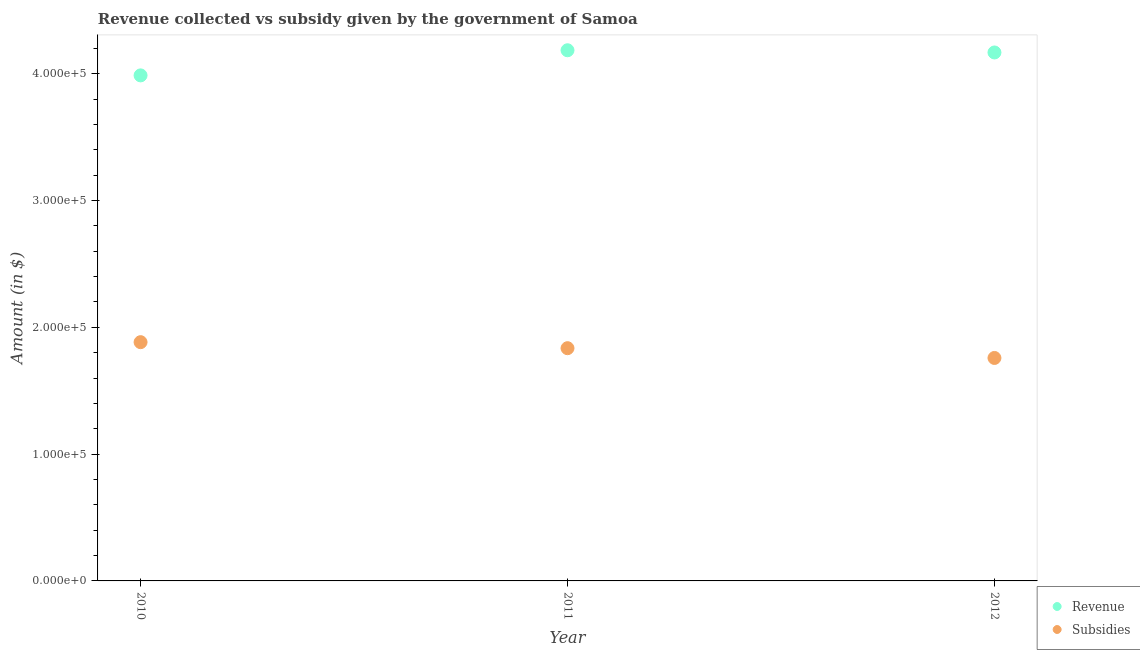What is the amount of subsidies given in 2012?
Your answer should be very brief. 1.76e+05. Across all years, what is the maximum amount of subsidies given?
Your response must be concise. 1.88e+05. Across all years, what is the minimum amount of revenue collected?
Offer a very short reply. 3.99e+05. What is the total amount of subsidies given in the graph?
Offer a very short reply. 5.48e+05. What is the difference between the amount of revenue collected in 2010 and that in 2011?
Your response must be concise. -1.98e+04. What is the difference between the amount of revenue collected in 2010 and the amount of subsidies given in 2012?
Provide a succinct answer. 2.23e+05. What is the average amount of subsidies given per year?
Provide a succinct answer. 1.83e+05. In the year 2011, what is the difference between the amount of revenue collected and amount of subsidies given?
Your answer should be very brief. 2.35e+05. In how many years, is the amount of subsidies given greater than 280000 $?
Give a very brief answer. 0. What is the ratio of the amount of subsidies given in 2010 to that in 2011?
Offer a very short reply. 1.03. Is the amount of subsidies given in 2010 less than that in 2012?
Make the answer very short. No. What is the difference between the highest and the second highest amount of revenue collected?
Provide a short and direct response. 1740.52. What is the difference between the highest and the lowest amount of revenue collected?
Make the answer very short. 1.98e+04. Does the amount of subsidies given monotonically increase over the years?
Ensure brevity in your answer.  No. Is the amount of subsidies given strictly greater than the amount of revenue collected over the years?
Give a very brief answer. No. What is the difference between two consecutive major ticks on the Y-axis?
Provide a succinct answer. 1.00e+05. Does the graph contain any zero values?
Provide a short and direct response. No. Does the graph contain grids?
Ensure brevity in your answer.  No. What is the title of the graph?
Your answer should be very brief. Revenue collected vs subsidy given by the government of Samoa. Does "Male labor force" appear as one of the legend labels in the graph?
Your answer should be very brief. No. What is the label or title of the Y-axis?
Give a very brief answer. Amount (in $). What is the Amount (in $) in Revenue in 2010?
Keep it short and to the point. 3.99e+05. What is the Amount (in $) of Subsidies in 2010?
Provide a short and direct response. 1.88e+05. What is the Amount (in $) in Revenue in 2011?
Make the answer very short. 4.19e+05. What is the Amount (in $) in Subsidies in 2011?
Keep it short and to the point. 1.84e+05. What is the Amount (in $) in Revenue in 2012?
Provide a short and direct response. 4.17e+05. What is the Amount (in $) in Subsidies in 2012?
Give a very brief answer. 1.76e+05. Across all years, what is the maximum Amount (in $) of Revenue?
Your answer should be very brief. 4.19e+05. Across all years, what is the maximum Amount (in $) of Subsidies?
Your answer should be very brief. 1.88e+05. Across all years, what is the minimum Amount (in $) of Revenue?
Keep it short and to the point. 3.99e+05. Across all years, what is the minimum Amount (in $) in Subsidies?
Your answer should be compact. 1.76e+05. What is the total Amount (in $) in Revenue in the graph?
Give a very brief answer. 1.23e+06. What is the total Amount (in $) in Subsidies in the graph?
Make the answer very short. 5.48e+05. What is the difference between the Amount (in $) in Revenue in 2010 and that in 2011?
Offer a very short reply. -1.98e+04. What is the difference between the Amount (in $) of Subsidies in 2010 and that in 2011?
Offer a very short reply. 4748.99. What is the difference between the Amount (in $) in Revenue in 2010 and that in 2012?
Provide a succinct answer. -1.81e+04. What is the difference between the Amount (in $) in Subsidies in 2010 and that in 2012?
Your answer should be very brief. 1.25e+04. What is the difference between the Amount (in $) of Revenue in 2011 and that in 2012?
Offer a terse response. 1740.52. What is the difference between the Amount (in $) of Subsidies in 2011 and that in 2012?
Your answer should be very brief. 7706.28. What is the difference between the Amount (in $) in Revenue in 2010 and the Amount (in $) in Subsidies in 2011?
Make the answer very short. 2.15e+05. What is the difference between the Amount (in $) of Revenue in 2010 and the Amount (in $) of Subsidies in 2012?
Ensure brevity in your answer.  2.23e+05. What is the difference between the Amount (in $) of Revenue in 2011 and the Amount (in $) of Subsidies in 2012?
Offer a terse response. 2.43e+05. What is the average Amount (in $) in Revenue per year?
Your response must be concise. 4.11e+05. What is the average Amount (in $) of Subsidies per year?
Your response must be concise. 1.83e+05. In the year 2010, what is the difference between the Amount (in $) in Revenue and Amount (in $) in Subsidies?
Give a very brief answer. 2.10e+05. In the year 2011, what is the difference between the Amount (in $) in Revenue and Amount (in $) in Subsidies?
Give a very brief answer. 2.35e+05. In the year 2012, what is the difference between the Amount (in $) of Revenue and Amount (in $) of Subsidies?
Provide a short and direct response. 2.41e+05. What is the ratio of the Amount (in $) in Revenue in 2010 to that in 2011?
Provide a short and direct response. 0.95. What is the ratio of the Amount (in $) in Subsidies in 2010 to that in 2011?
Your answer should be very brief. 1.03. What is the ratio of the Amount (in $) of Revenue in 2010 to that in 2012?
Your answer should be compact. 0.96. What is the ratio of the Amount (in $) of Subsidies in 2010 to that in 2012?
Provide a short and direct response. 1.07. What is the ratio of the Amount (in $) of Subsidies in 2011 to that in 2012?
Provide a succinct answer. 1.04. What is the difference between the highest and the second highest Amount (in $) in Revenue?
Provide a succinct answer. 1740.52. What is the difference between the highest and the second highest Amount (in $) of Subsidies?
Your response must be concise. 4748.99. What is the difference between the highest and the lowest Amount (in $) of Revenue?
Provide a short and direct response. 1.98e+04. What is the difference between the highest and the lowest Amount (in $) of Subsidies?
Offer a very short reply. 1.25e+04. 